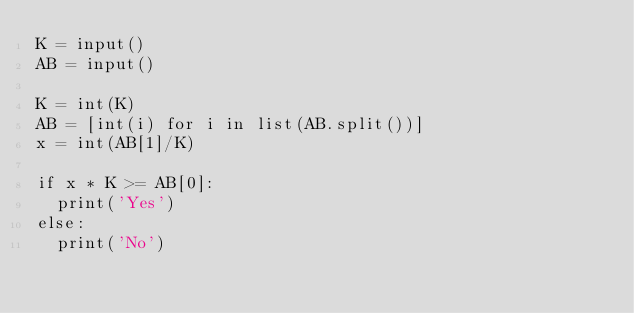<code> <loc_0><loc_0><loc_500><loc_500><_Python_>K = input()
AB = input()

K = int(K)
AB = [int(i) for i in list(AB.split())]
x = int(AB[1]/K)

if x * K >= AB[0]:
  print('Yes')
else:
  print('No')</code> 